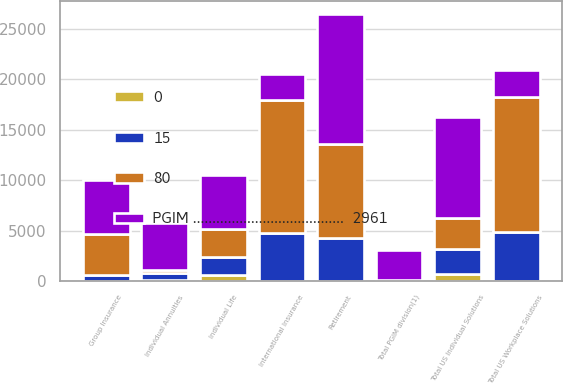Convert chart. <chart><loc_0><loc_0><loc_500><loc_500><stacked_bar_chart><ecel><fcel>Total PGIM division(1)<fcel>Retirement<fcel>Group Insurance<fcel>Total US Workplace Solutions<fcel>Individual Annuities<fcel>Individual Life<fcel>Total US Individual Solutions<fcel>International Insurance<nl><fcel>PGIM .......................................  2961<fcel>2961<fcel>12876<fcel>5343<fcel>2635<fcel>4666<fcel>5355<fcel>10021<fcel>2635<nl><fcel>15<fcel>80<fcel>4263<fcel>608<fcel>4871<fcel>698<fcel>1822<fcel>2520<fcel>4759<nl><fcel>80<fcel>0<fcel>9328<fcel>4032<fcel>13360<fcel>306<fcel>2750<fcel>3056<fcel>13183<nl><fcel>0<fcel>15<fcel>19<fcel>5<fcel>24<fcel>71<fcel>583<fcel>654<fcel>8<nl></chart> 